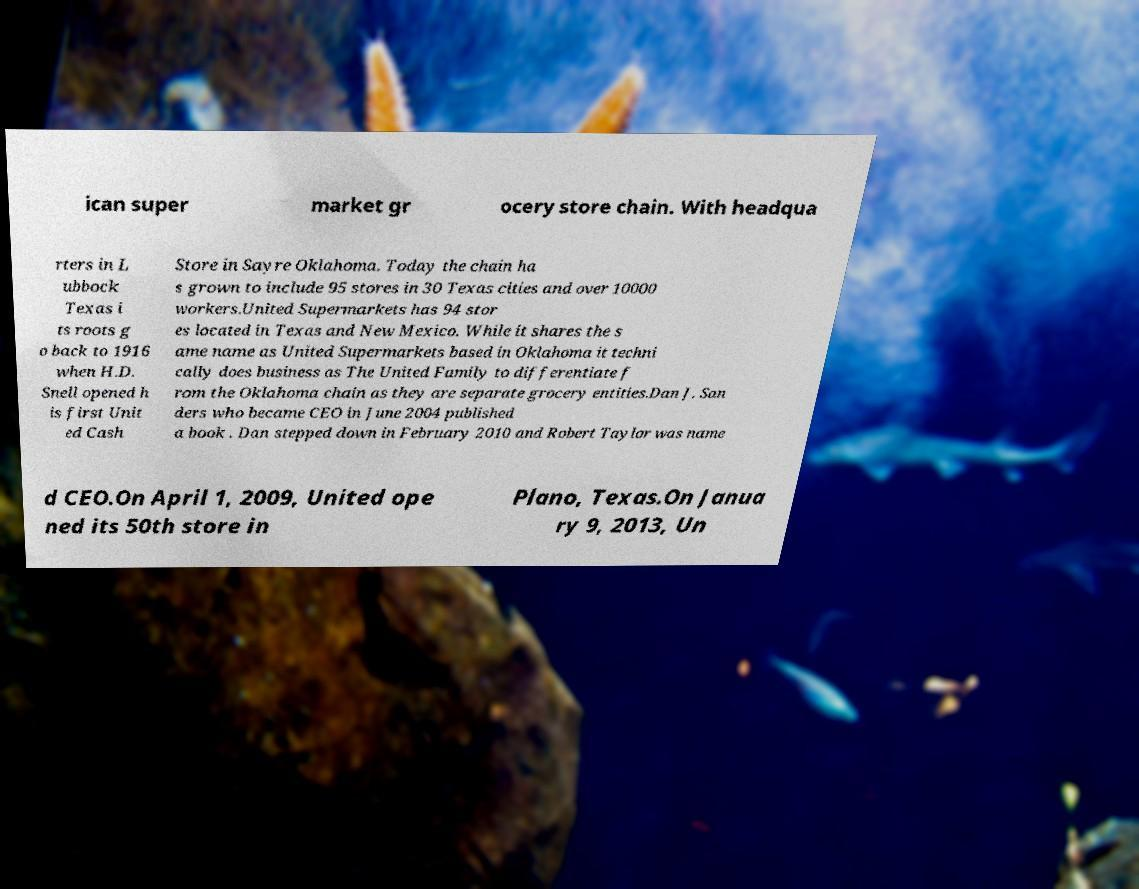Please identify and transcribe the text found in this image. ican super market gr ocery store chain. With headqua rters in L ubbock Texas i ts roots g o back to 1916 when H.D. Snell opened h is first Unit ed Cash Store in Sayre Oklahoma. Today the chain ha s grown to include 95 stores in 30 Texas cities and over 10000 workers.United Supermarkets has 94 stor es located in Texas and New Mexico. While it shares the s ame name as United Supermarkets based in Oklahoma it techni cally does business as The United Family to differentiate f rom the Oklahoma chain as they are separate grocery entities.Dan J. San ders who became CEO in June 2004 published a book . Dan stepped down in February 2010 and Robert Taylor was name d CEO.On April 1, 2009, United ope ned its 50th store in Plano, Texas.On Janua ry 9, 2013, Un 